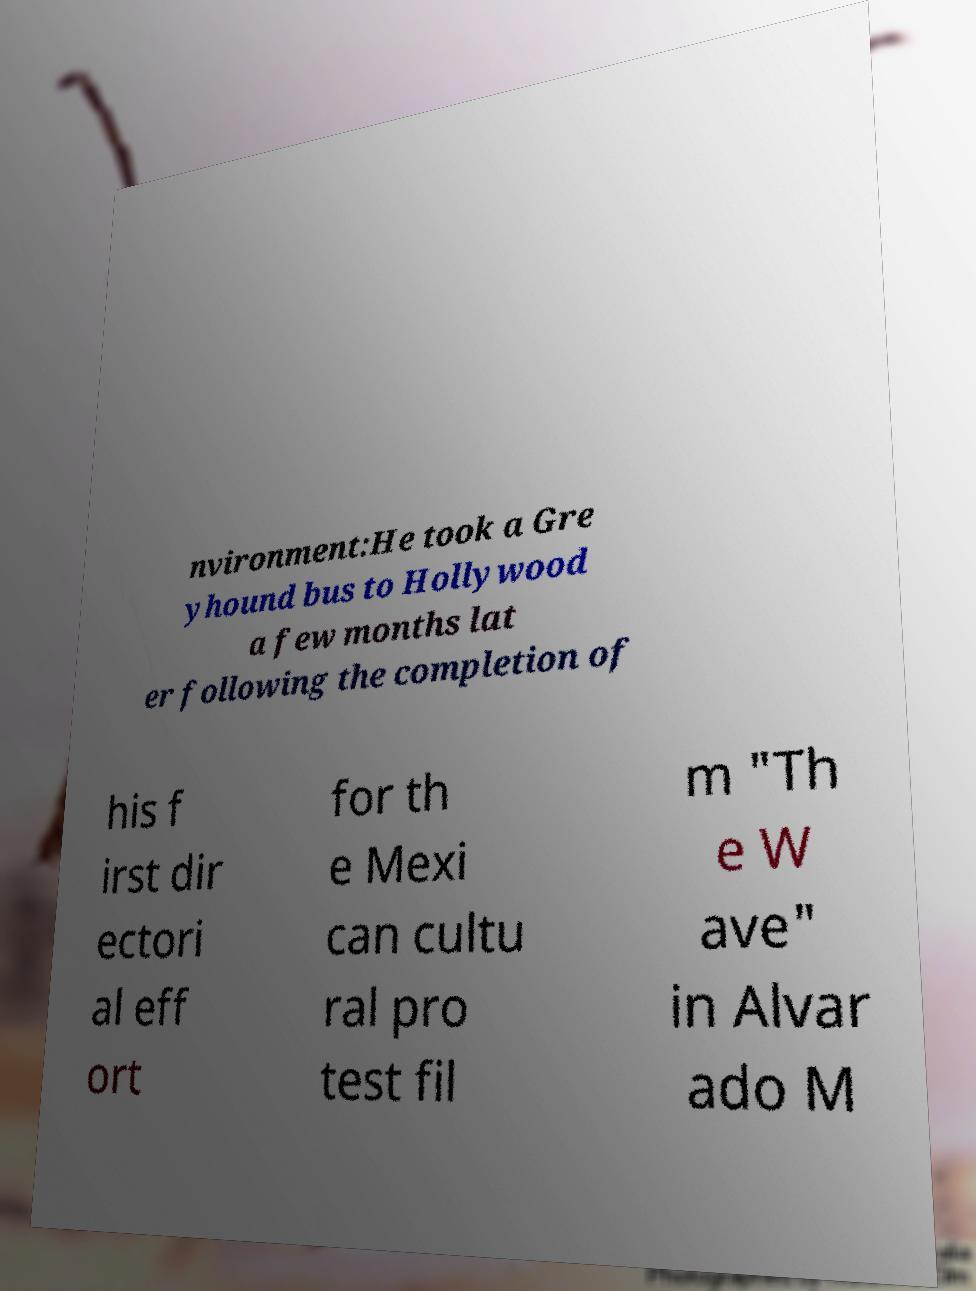For documentation purposes, I need the text within this image transcribed. Could you provide that? nvironment:He took a Gre yhound bus to Hollywood a few months lat er following the completion of his f irst dir ectori al eff ort for th e Mexi can cultu ral pro test fil m "Th e W ave" in Alvar ado M 